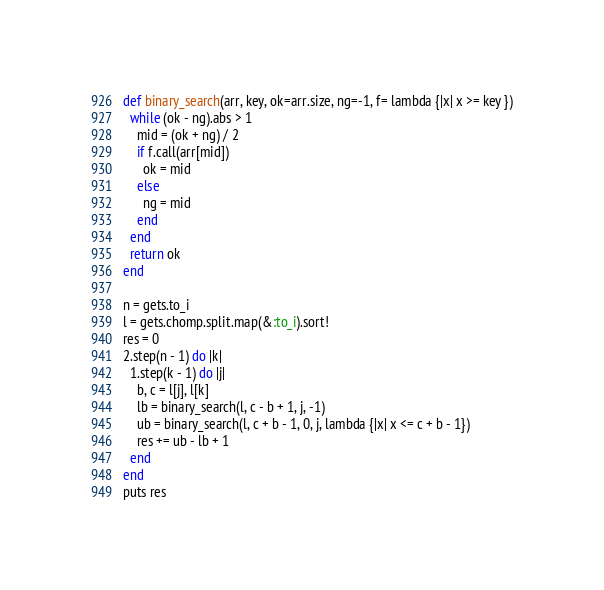Convert code to text. <code><loc_0><loc_0><loc_500><loc_500><_Ruby_>def binary_search(arr, key, ok=arr.size, ng=-1, f= lambda {|x| x >= key })
  while (ok - ng).abs > 1
    mid = (ok + ng) / 2
    if f.call(arr[mid])
      ok = mid
    else
      ng = mid
    end
  end
  return ok
end

n = gets.to_i
l = gets.chomp.split.map(&:to_i).sort!
res = 0
2.step(n - 1) do |k|
  1.step(k - 1) do |j|
    b, c = l[j], l[k]
    lb = binary_search(l, c - b + 1, j, -1)
    ub = binary_search(l, c + b - 1, 0, j, lambda {|x| x <= c + b - 1})
    res += ub - lb + 1
  end
end
puts res</code> 